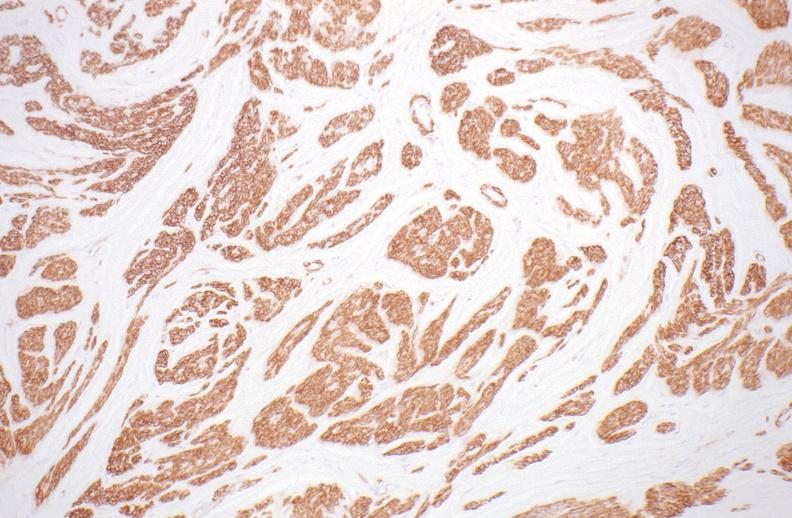does this image show leiomyoma?
Answer the question using a single word or phrase. Yes 